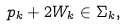Convert formula to latex. <formula><loc_0><loc_0><loc_500><loc_500>p _ { k } + 2 W _ { k } \in \Sigma _ { k } ,</formula> 